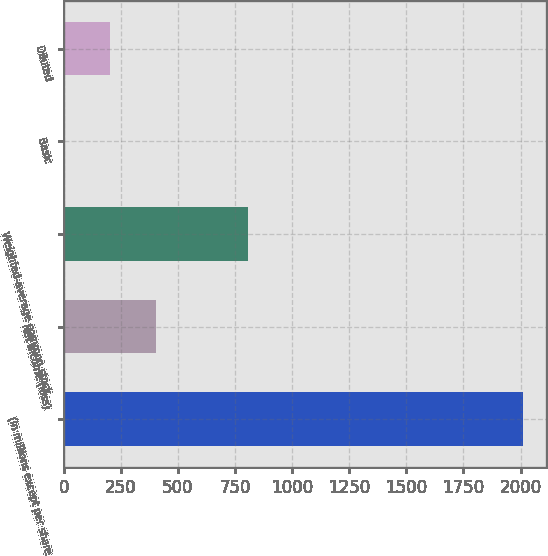Convert chart. <chart><loc_0><loc_0><loc_500><loc_500><bar_chart><fcel>(In millions except per share<fcel>Net income (loss)<fcel>Weighted-average common stock<fcel>Basic<fcel>Diluted<nl><fcel>2012<fcel>402.59<fcel>804.95<fcel>0.23<fcel>201.41<nl></chart> 